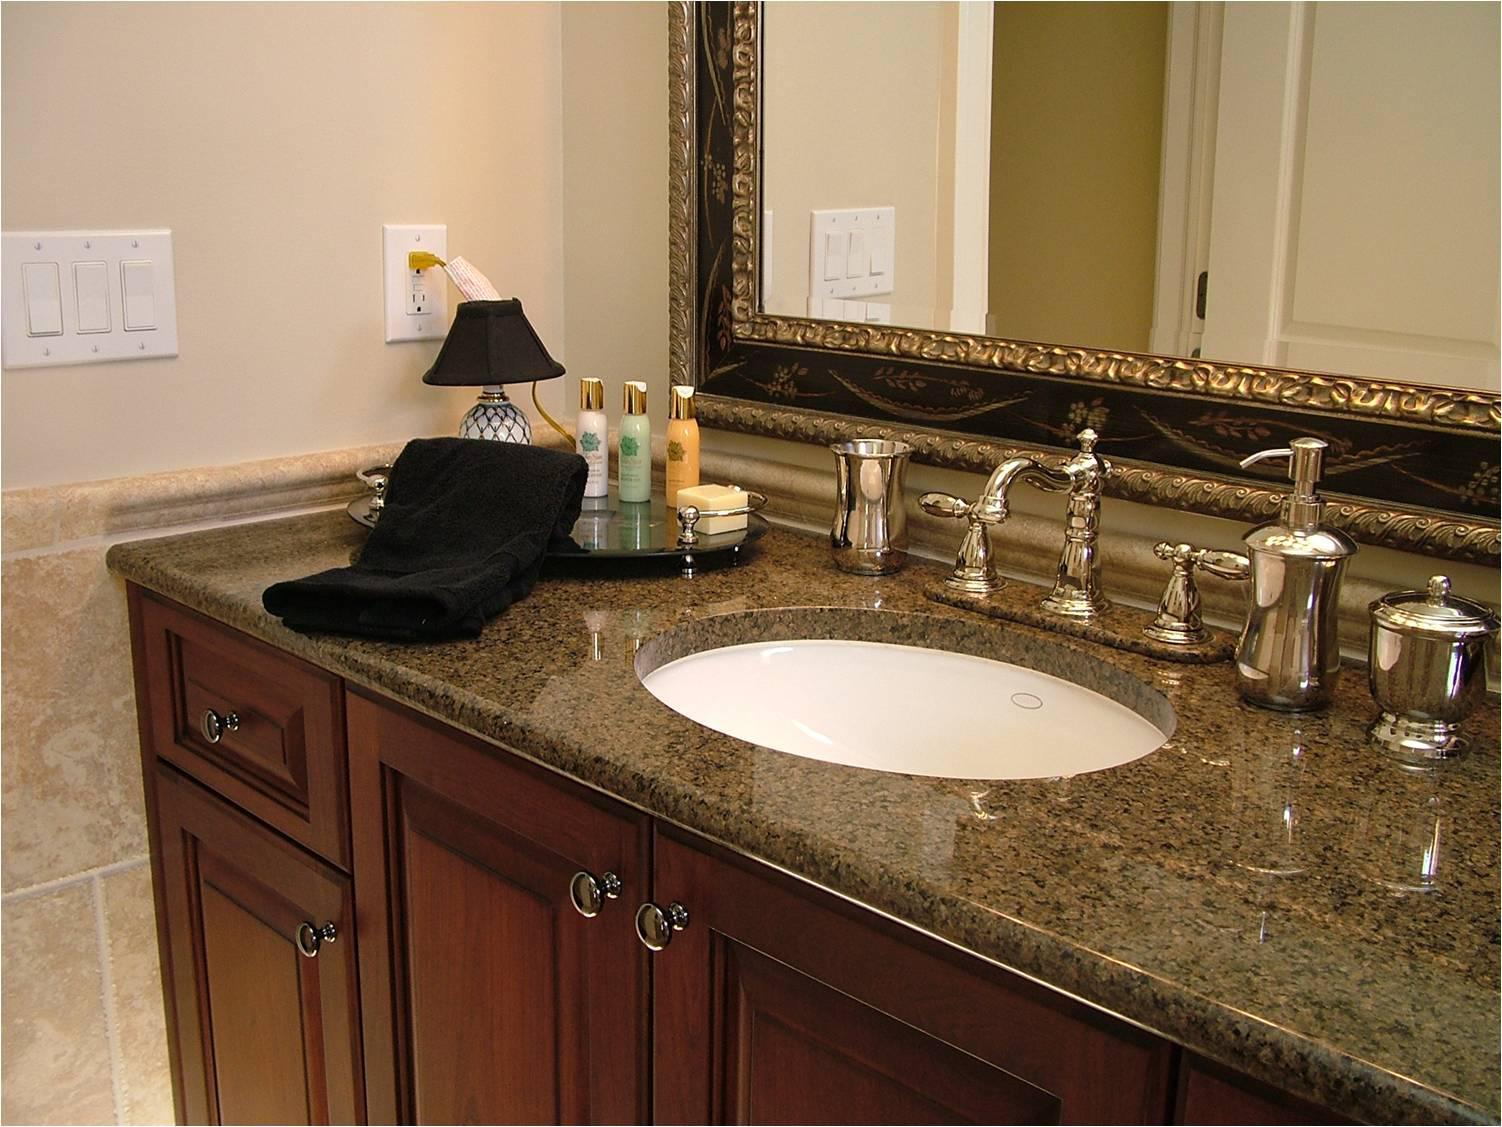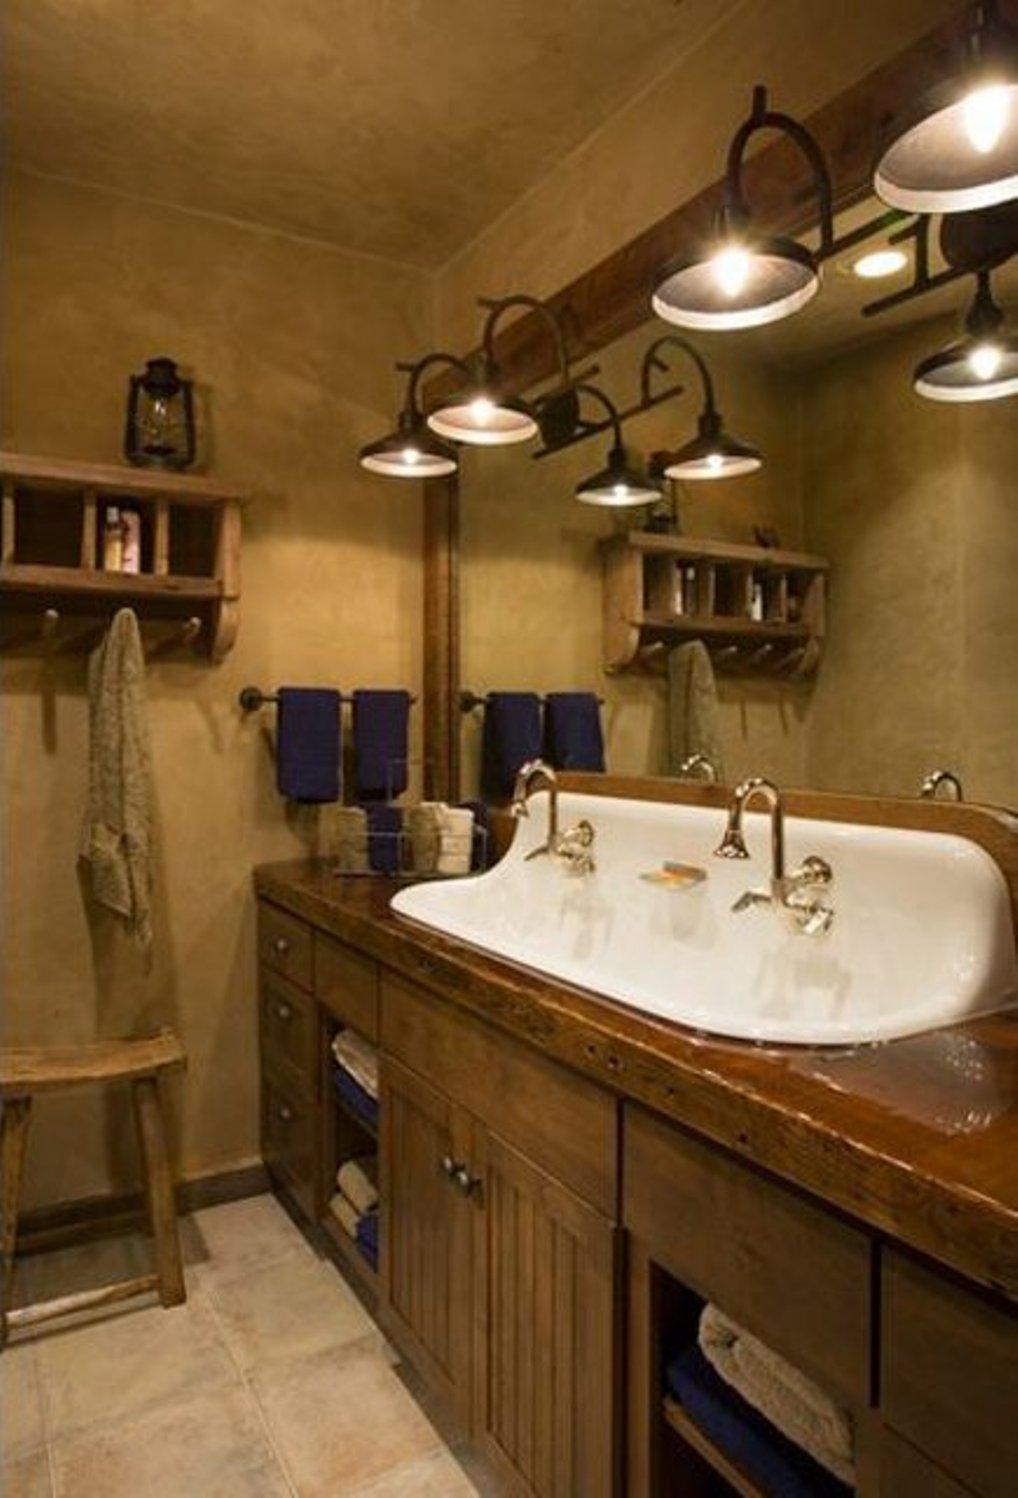The first image is the image on the left, the second image is the image on the right. Analyze the images presented: Is the assertion "A mirror sits above the sink in the image on the left." valid? Answer yes or no. Yes. 